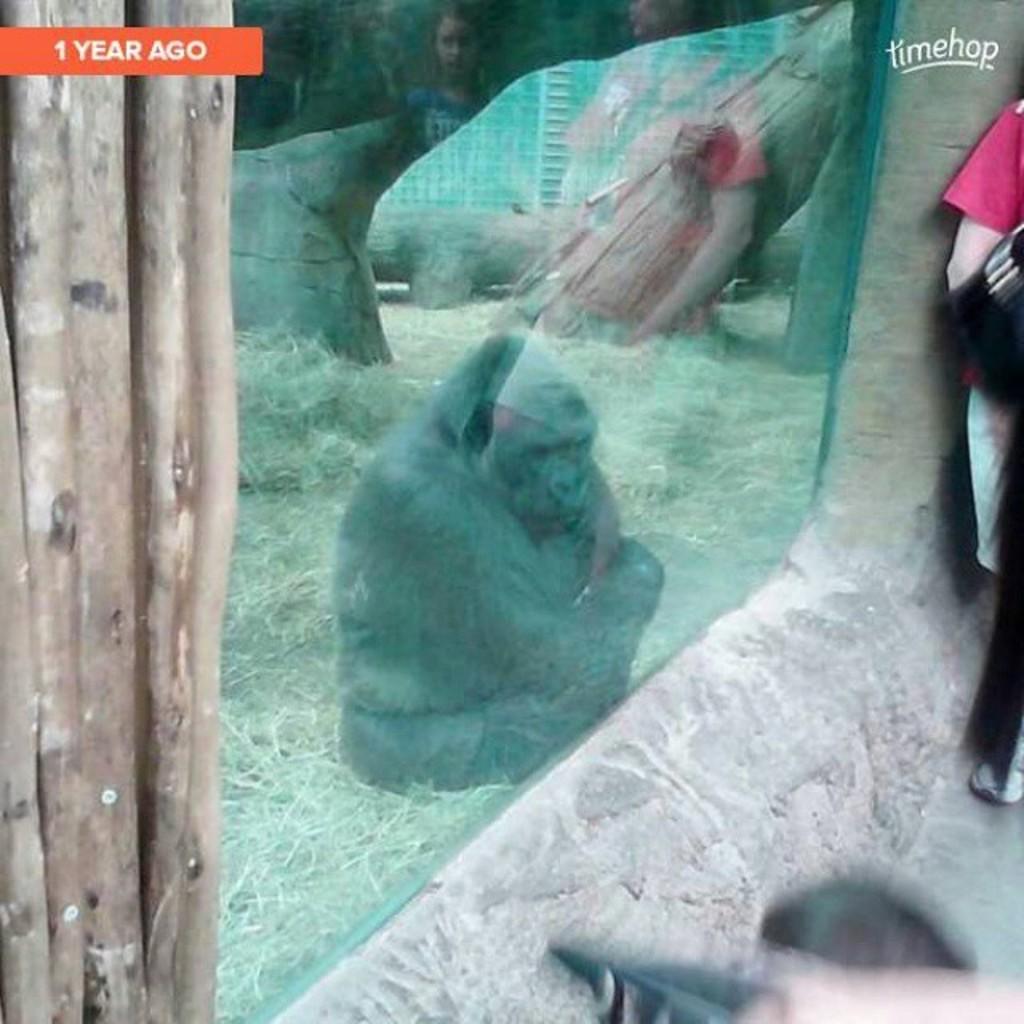How would you summarize this image in a sentence or two? In this image we can see a person standing and wooden sticks here. Here we can see the glass windows through which we can see gorilla sitting on the grass, rocks and fence in the background. 